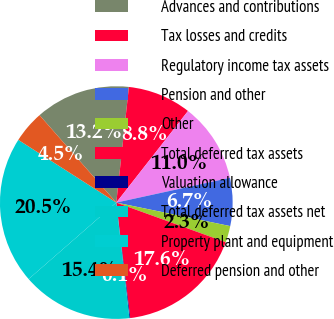<chart> <loc_0><loc_0><loc_500><loc_500><pie_chart><fcel>Advances and contributions<fcel>Tax losses and credits<fcel>Regulatory income tax assets<fcel>Pension and other<fcel>Other<fcel>Total deferred tax assets<fcel>Valuation allowance<fcel>Total deferred tax assets net<fcel>Property plant and equipment<fcel>Deferred pension and other<nl><fcel>13.2%<fcel>8.84%<fcel>11.02%<fcel>6.65%<fcel>2.29%<fcel>17.56%<fcel>0.11%<fcel>15.38%<fcel>20.48%<fcel>4.47%<nl></chart> 